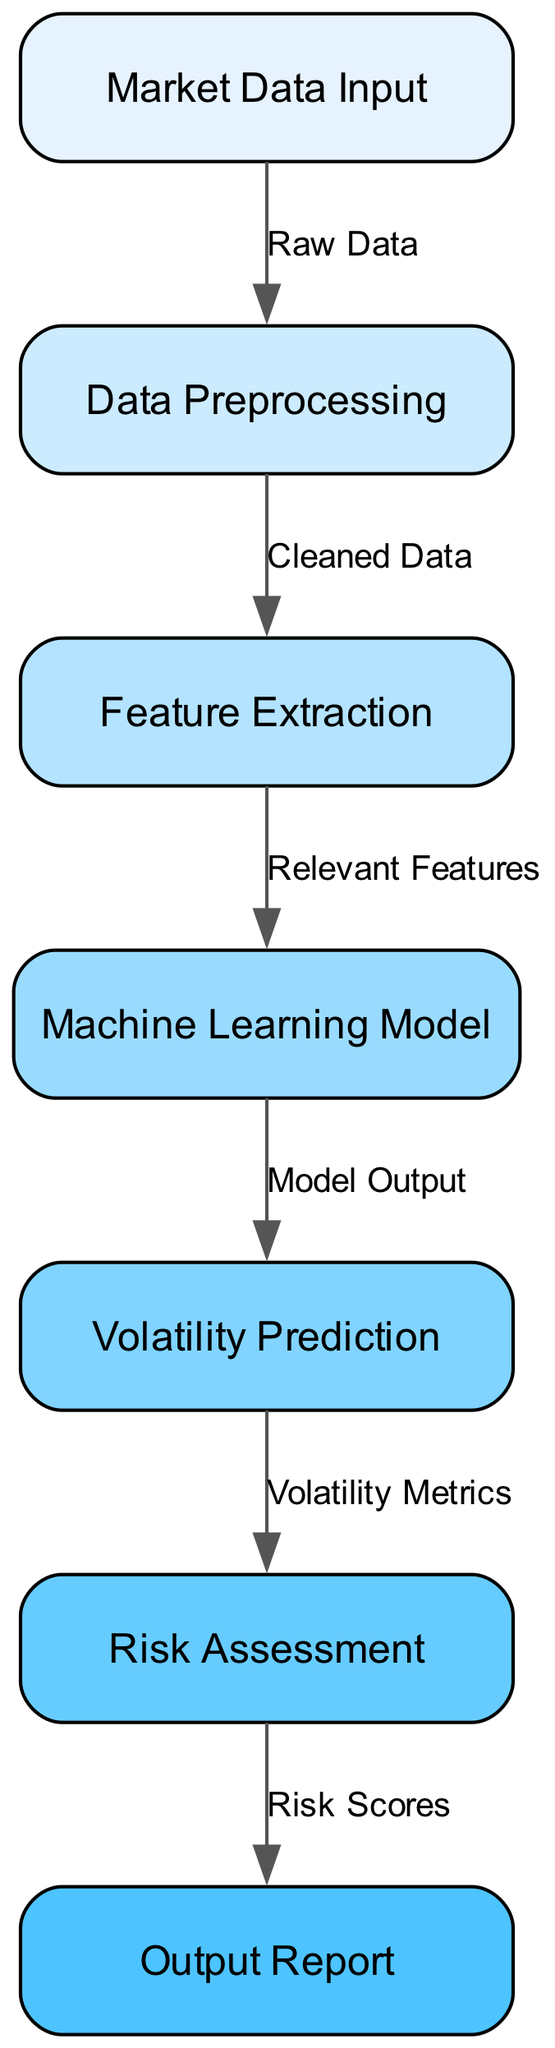What is the first step in the algorithm-based risk assessment model? The first step in the model is "Market Data Input," as it is the initial node that receives the raw data.
Answer: Market Data Input How many nodes are there in the diagram? The diagram features seven nodes: Market Data Input, Data Preprocessing, Feature Extraction, Machine Learning Model, Volatility Prediction, Risk Assessment, and Output Report.
Answer: Seven What is the label on the edge from Data Preprocessing to Feature Extraction? The label on the edge from Data Preprocessing to Feature Extraction is "Cleaned Data," indicating the type of data being passed along this connection.
Answer: Cleaned Data Which node outputs Volatility Metrics? The node that outputs Volatility Metrics is "Volatility Prediction," after processing the model output from the Machine Learning Model.
Answer: Volatility Prediction What is the last output of the risk assessment model? The last output of the model is the "Output Report," which consolidates the data from the Risk Assessment.
Answer: Output Report What type of data is passed from Feature Extraction to the Machine Learning Model? The data passed from Feature Extraction to the Machine Learning Model is labeled as "Relevant Features," signifying that these features are essential for model training.
Answer: Relevant Features Which node connects to the Risk Assessment node? The node that connects to the Risk Assessment node is "Volatility Prediction," which provides the necessary metrics for this assessment step.
Answer: Volatility Prediction What is the relationship between Machine Learning Model and Volatility Prediction? The relationship is indicated by the edge labeled "Model Output," meaning the Machine Learning Model provides output that leads to the prediction of market volatility.
Answer: Model Output 